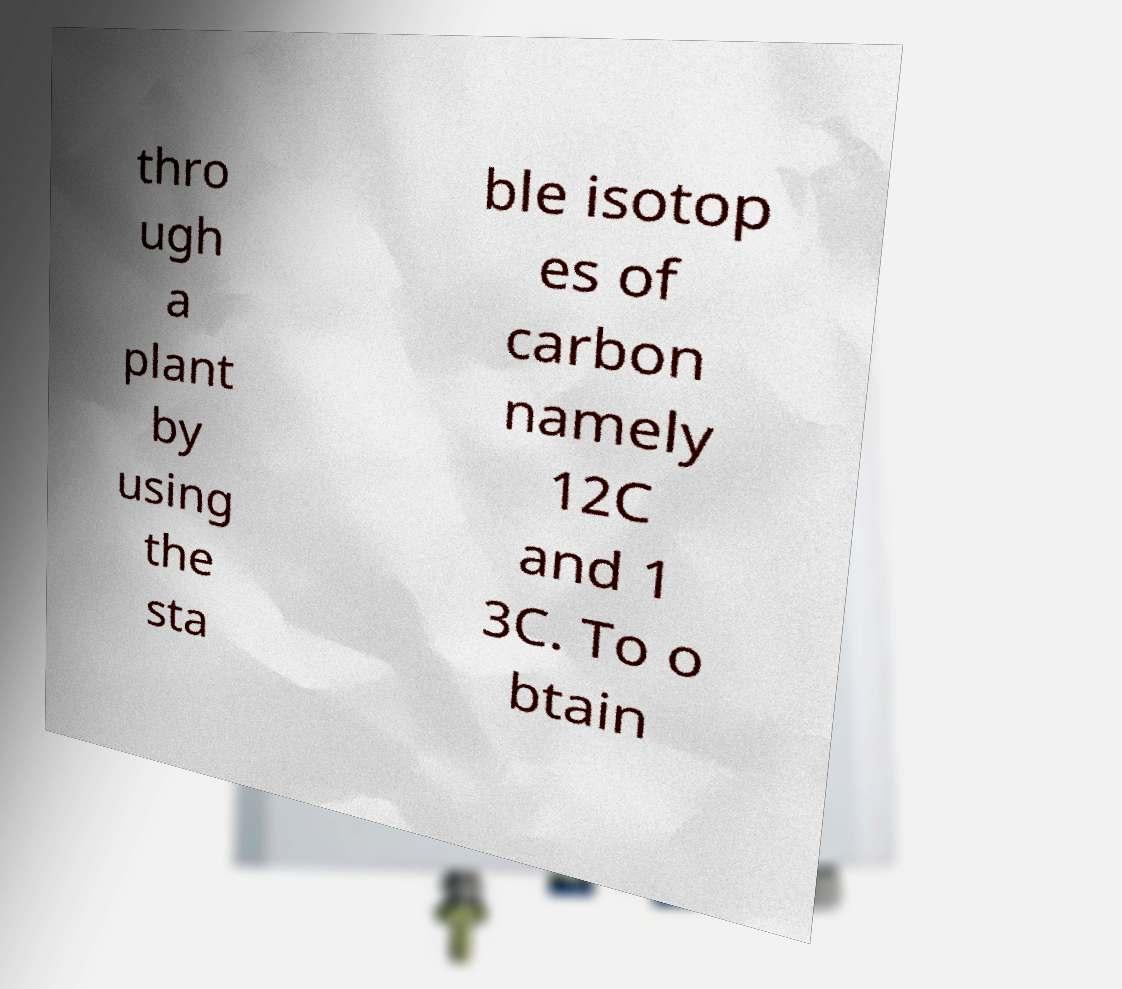Please identify and transcribe the text found in this image. thro ugh a plant by using the sta ble isotop es of carbon namely 12C and 1 3C. To o btain 